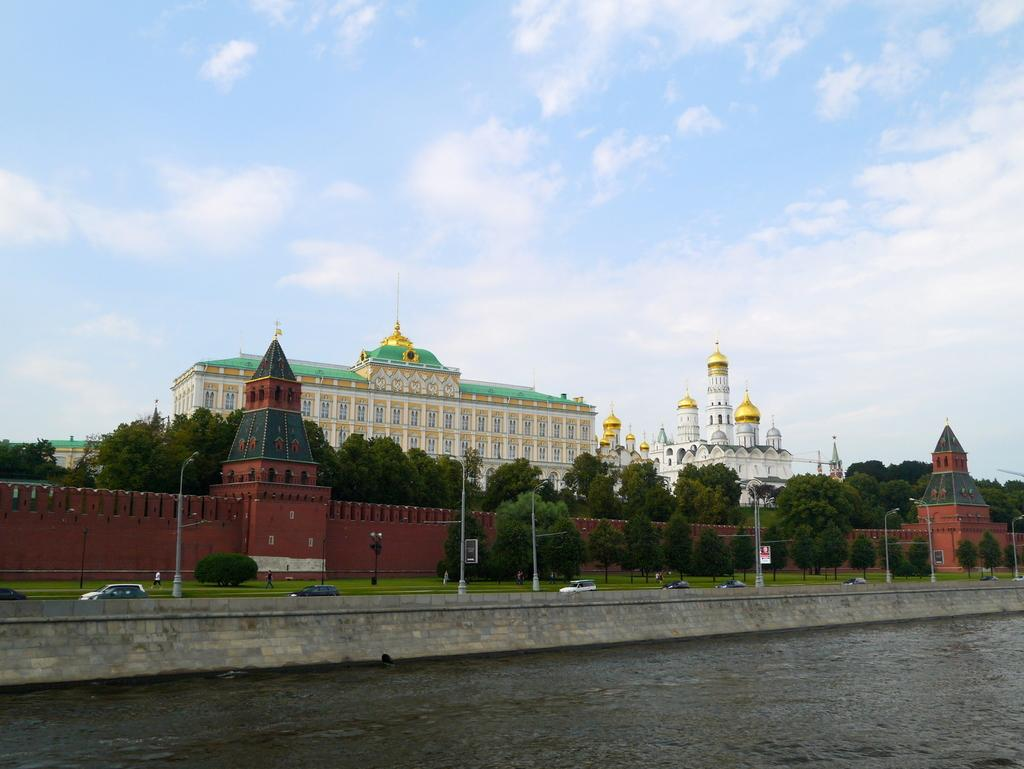What is at the bottom of the image? There is water at the bottom of the image. What can be seen in the middle of the image? Vehicles are present in the middle of the image. What type of vegetation is visible in the background of the image? There is grass in the background of the image. What other features can be seen in the background of the image? Trees and a building are visible in the background of the image. Can you identify any specific type of building in the background? Yes, a mosque is present in the background of the image. What type of paint is being used by the vehicles in the image? There is no indication in the image that the vehicles are being painted or using paint. How many tickets are visible in the image? There are no tickets present in the image. 